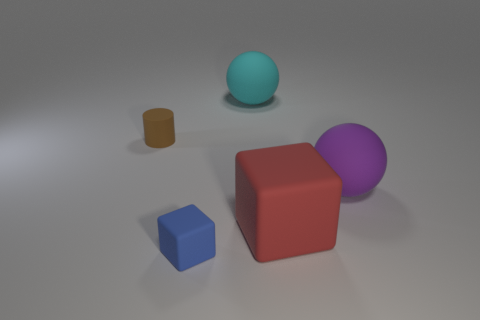Are there fewer red blocks than matte spheres?
Give a very brief answer. Yes. There is a thing that is both in front of the purple matte ball and behind the blue thing; what is its size?
Ensure brevity in your answer.  Large. Is the color of the rubber sphere that is left of the big red rubber block the same as the tiny block?
Your answer should be very brief. No. Are there fewer large cyan spheres that are on the left side of the blue matte cube than cyan spheres?
Offer a terse response. Yes. There is a purple object that is the same material as the big red thing; what shape is it?
Ensure brevity in your answer.  Sphere. Is the big red cube made of the same material as the purple object?
Offer a very short reply. Yes. Is the number of cyan things left of the blue rubber block less than the number of matte cylinders on the right side of the tiny rubber cylinder?
Give a very brief answer. No. How many big red objects are on the right side of the large red matte cube on the left side of the matte sphere right of the cyan rubber sphere?
Your answer should be very brief. 0. Is the color of the small cylinder the same as the tiny cube?
Your answer should be compact. No. Are there any other tiny rubber cylinders of the same color as the cylinder?
Give a very brief answer. No. 